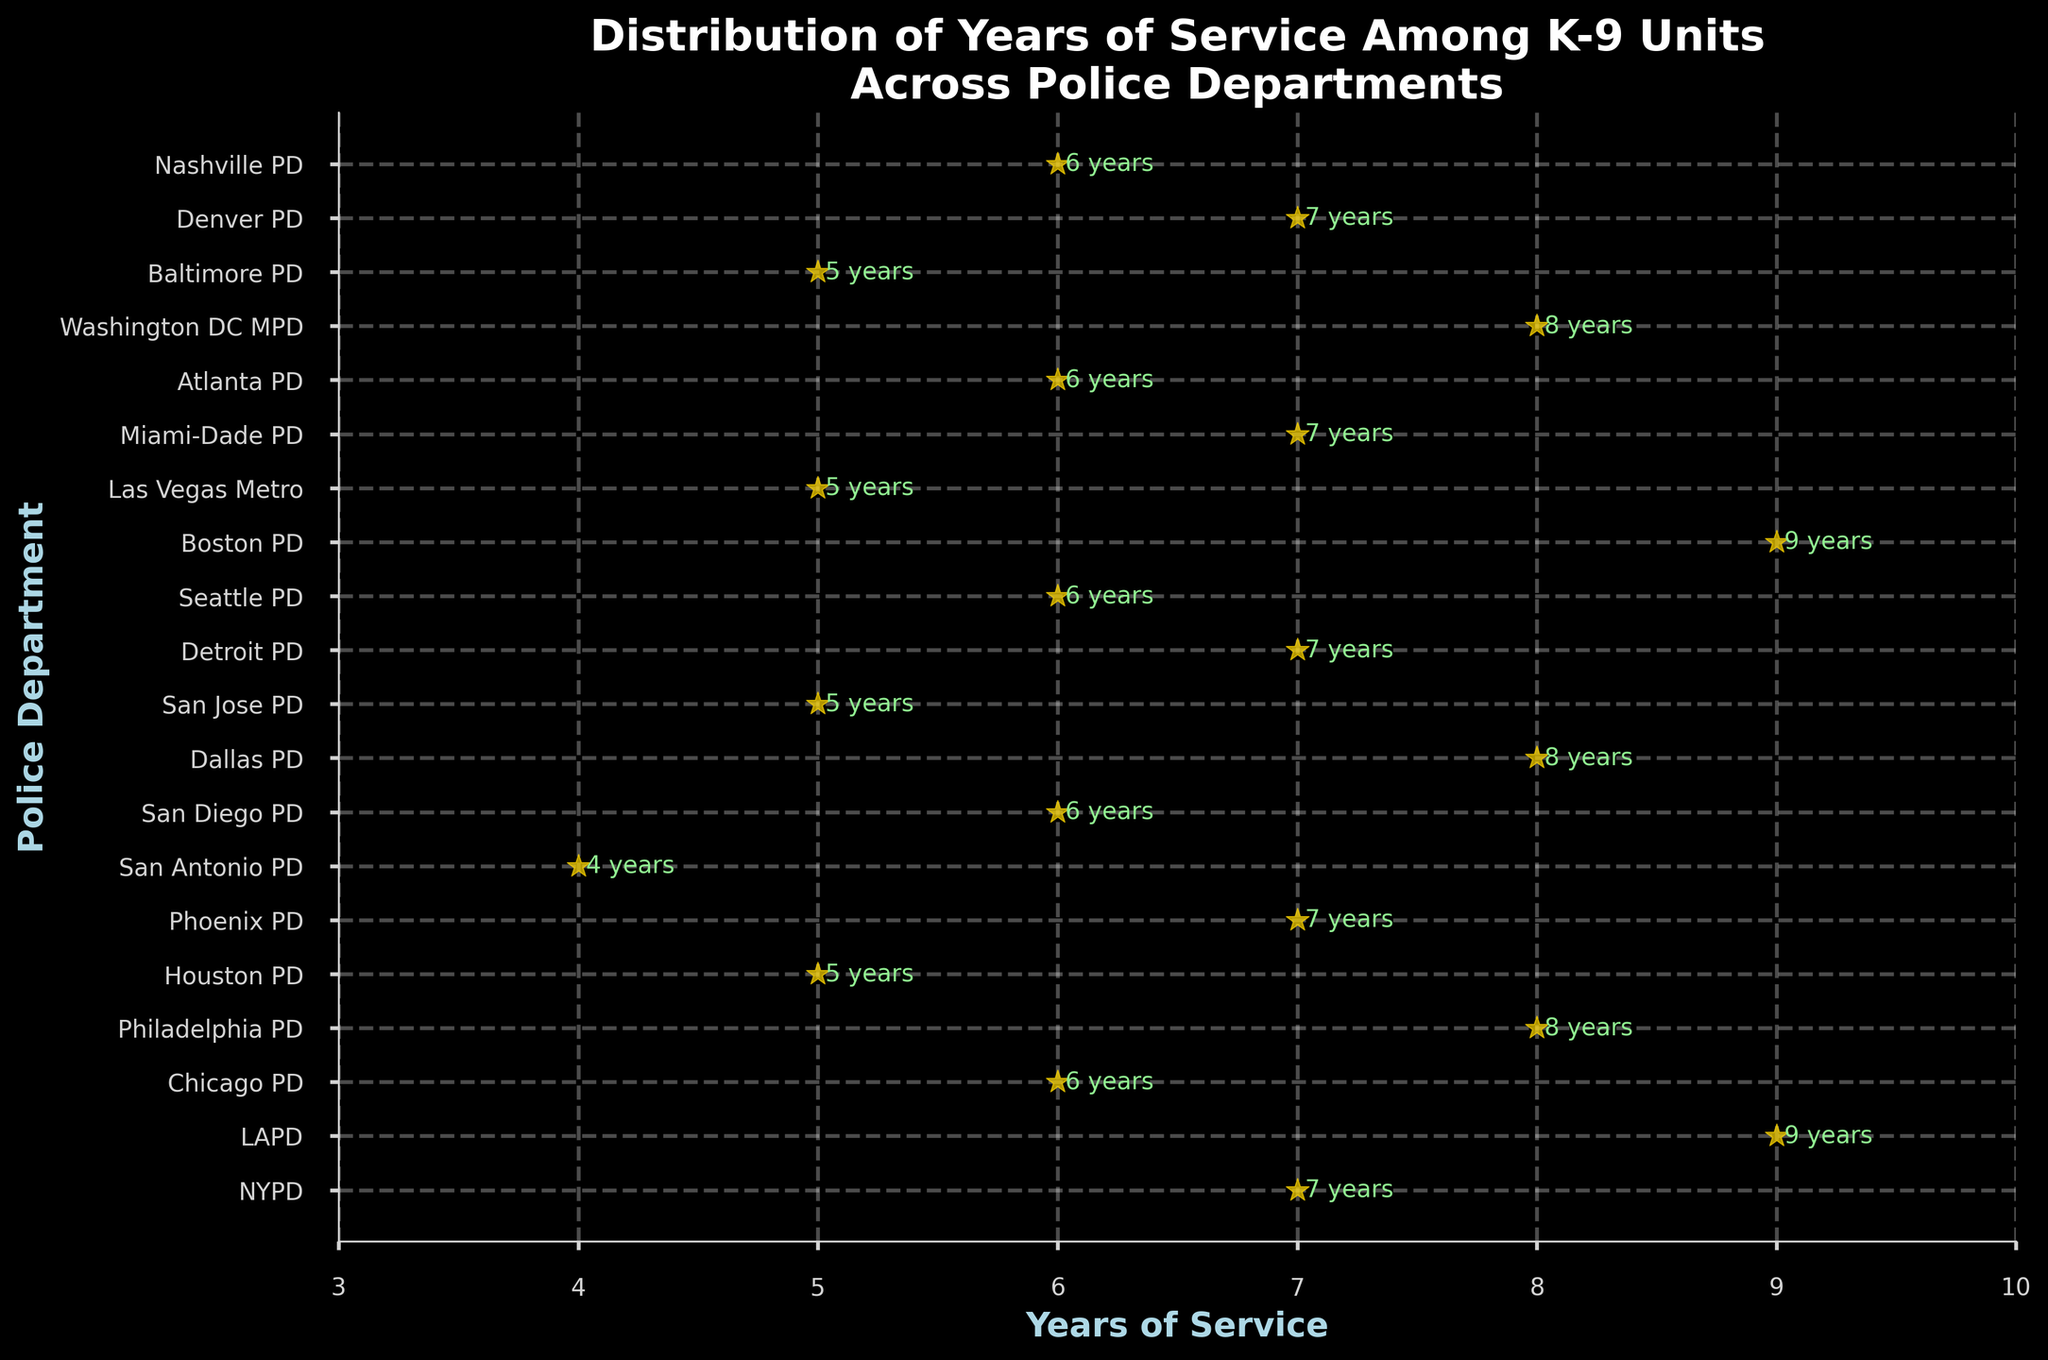How many departments have K-9 units with 7 years of service? By inspecting the graph, we count the number of points aligned with 7 years of service.
Answer: 5 Which department has the highest years of service? Look for the data point that is highest on the x-axis, which corresponds to the largest number of years.
Answer: LAPD and Boston PD What is the average years of service across all departments? Sum all years of service and divide by the number of departments: (7+9+6+8+5+7+4+6+8+5+7+6+9+5+7+6+8+5+7+6) / 20
Answer: 6.5 Is there a significant difference between the department with the highest service and the department with the lowest service? Identify the highest (9 years) and the lowest (4 years) and calculate their difference: 9 - 4
Answer: 5 Are there more departments with years of service above or below 6 years? Count departments with years above 6 (7, 8, 9) and those below (4, 5, 6). Departments above 6: 10, Departments below 6: 10.
Answer: They are equal Which departments have more years of service than San Diego PD? San Diego PD has 6 years. Identify departments with more than 6 years of service: NYPD, LAPD, Philadelphia PD, Dallas PD, Boston PD, Washington DC MPD
Answer: 6 departments What is the median years of service? Order the years from lowest to highest and find the middle value. If even, average the two middle values: (4, 5, 5, 5, 5, 6, 6, 6, 6, 6, 7, 7, 7, 7, 7, 8, 8, 8, 9, 9). Median is (6+6)/2
Answer: 6 Which department has exactly 7 years of service? NYPD, Phoenix PD, Detroit PD, Miami-Dade PD, Denver PD all have 7 years according to the scatter plot labels.
Answer: 5 departments Are there more departments with 5 years of service or with 6 years of service? Count the departments with 5 years (Houston, San Jose, Las Vegas Metro, Baltimore) and with 6 years (Chicago, San Diego, Seattle, Atlanta, Nashville).
Answer: More departments with 6 years What is the range of years of service among the K-9 units across the departments? The range is the difference between the maximum and minimum years of service: 9 - 4.
Answer: 5 